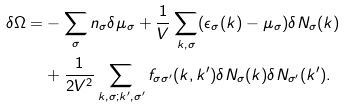<formula> <loc_0><loc_0><loc_500><loc_500>\delta \Omega = & - \sum _ { \sigma } n _ { \sigma } \delta \mu _ { \sigma } + \frac { 1 } { V } \sum _ { k , \sigma } ( \epsilon _ { \sigma } ( k ) - \mu _ { \sigma } ) \delta N _ { \sigma } ( k ) \\ & + \frac { 1 } { 2 V ^ { 2 } } \sum _ { k , \sigma ; k ^ { \prime } , \sigma ^ { \prime } } f _ { \sigma \sigma ^ { \prime } } ( k , k ^ { \prime } ) \delta N _ { \sigma } ( k ) \delta N _ { \sigma ^ { \prime } } ( k ^ { \prime } ) .</formula> 